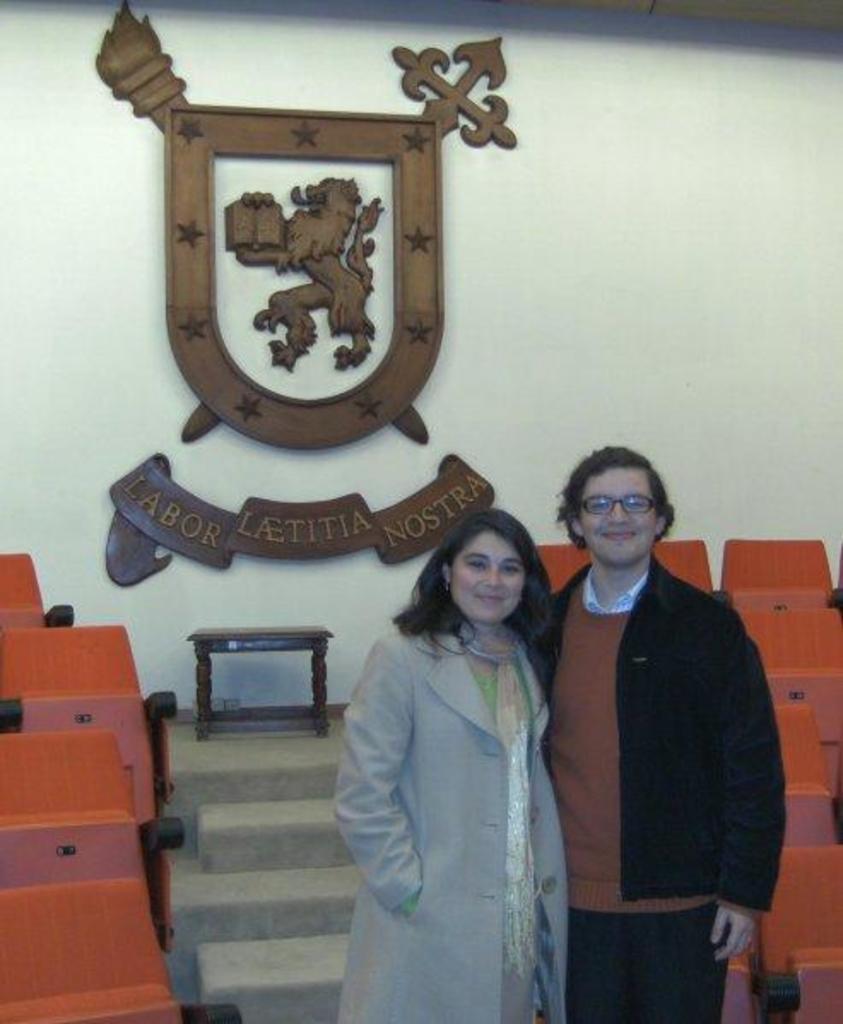Describe this image in one or two sentences. In this picture there are two people standing and we can see chairs, steps and emblem on the wall. 